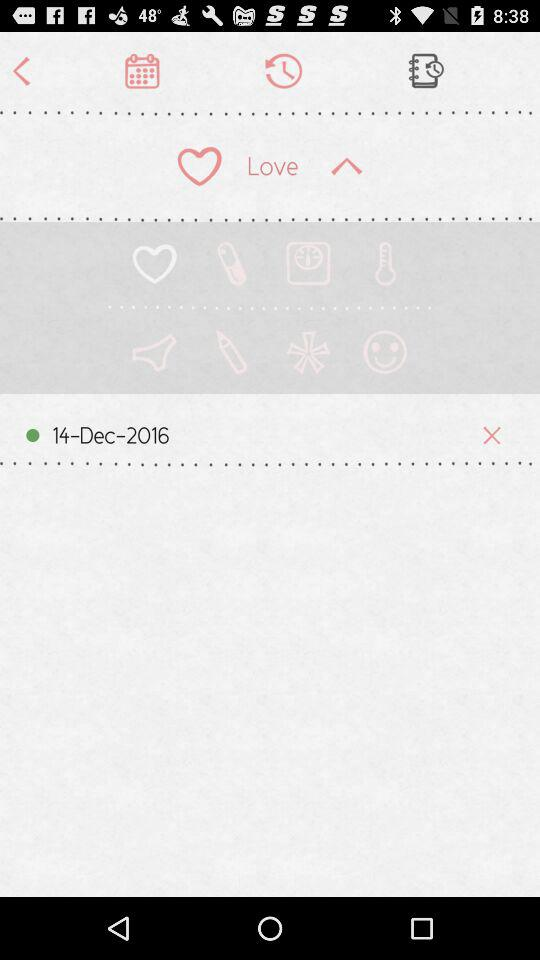What is the referral code?
When the provided information is insufficient, respond with <no answer>. <no answer> 